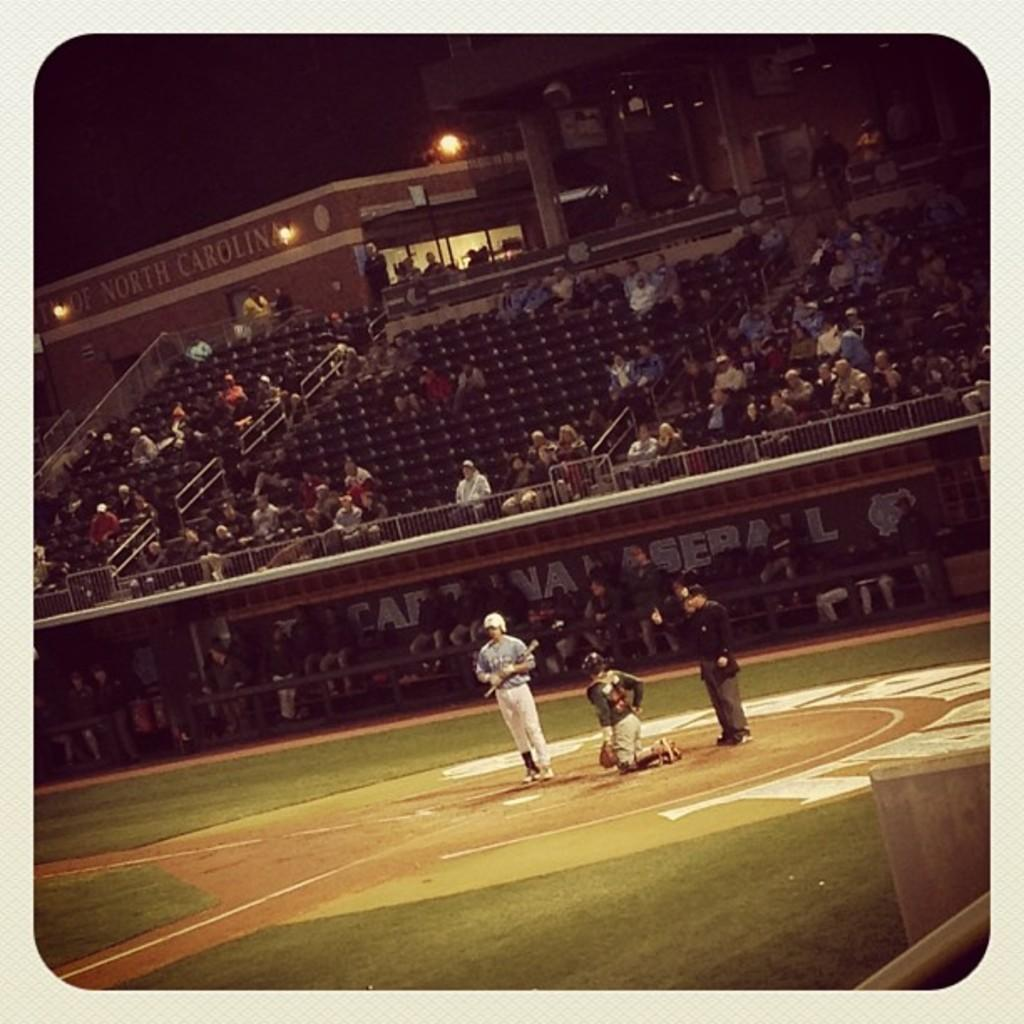<image>
Offer a succinct explanation of the picture presented. A few fans are in the stands of a baseball game at the University of North Carolina. 